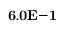<formula> <loc_0><loc_0><loc_500><loc_500>{ 6 . 0 E { - 1 } }</formula> 